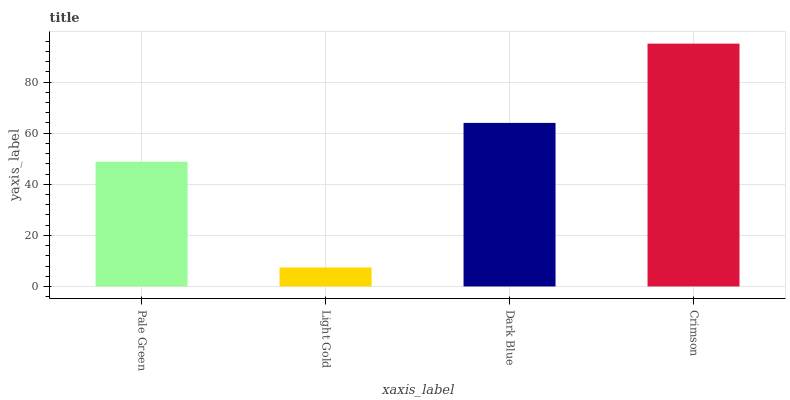Is Light Gold the minimum?
Answer yes or no. Yes. Is Crimson the maximum?
Answer yes or no. Yes. Is Dark Blue the minimum?
Answer yes or no. No. Is Dark Blue the maximum?
Answer yes or no. No. Is Dark Blue greater than Light Gold?
Answer yes or no. Yes. Is Light Gold less than Dark Blue?
Answer yes or no. Yes. Is Light Gold greater than Dark Blue?
Answer yes or no. No. Is Dark Blue less than Light Gold?
Answer yes or no. No. Is Dark Blue the high median?
Answer yes or no. Yes. Is Pale Green the low median?
Answer yes or no. Yes. Is Light Gold the high median?
Answer yes or no. No. Is Dark Blue the low median?
Answer yes or no. No. 